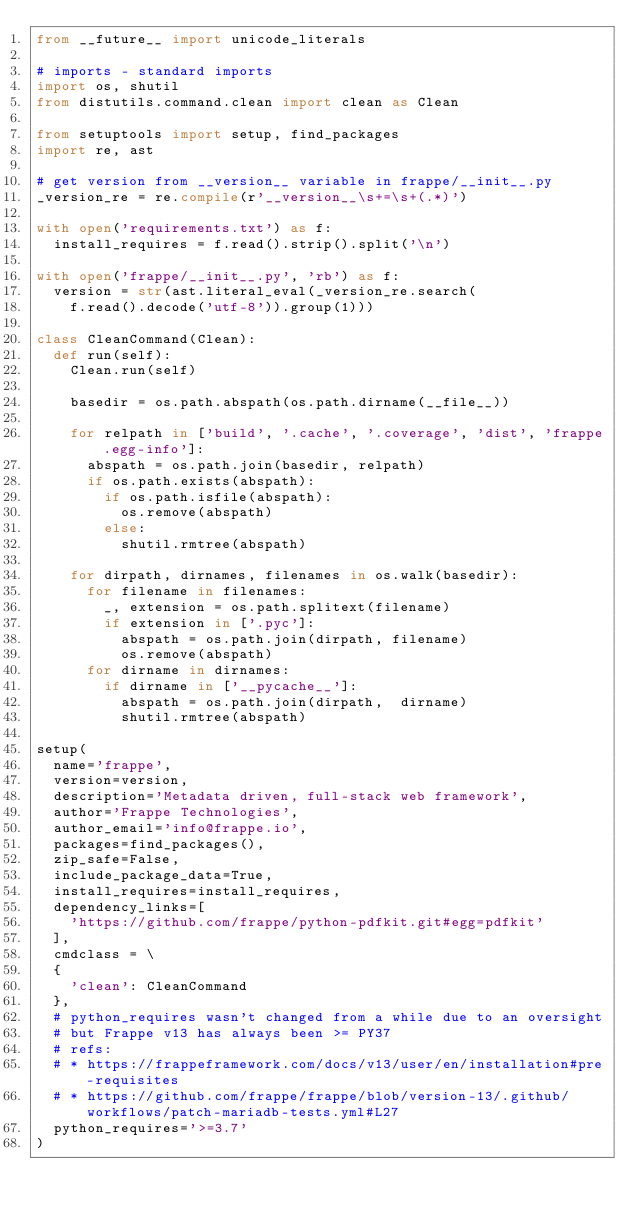<code> <loc_0><loc_0><loc_500><loc_500><_Python_>from __future__ import unicode_literals

# imports - standard imports
import os, shutil
from distutils.command.clean import clean as Clean

from setuptools import setup, find_packages
import re, ast

# get version from __version__ variable in frappe/__init__.py
_version_re = re.compile(r'__version__\s+=\s+(.*)')

with open('requirements.txt') as f:
	install_requires = f.read().strip().split('\n')

with open('frappe/__init__.py', 'rb') as f:
	version = str(ast.literal_eval(_version_re.search(
		f.read().decode('utf-8')).group(1)))

class CleanCommand(Clean):
	def run(self):
		Clean.run(self)

		basedir = os.path.abspath(os.path.dirname(__file__))

		for relpath in ['build', '.cache', '.coverage', 'dist', 'frappe.egg-info']:
			abspath = os.path.join(basedir, relpath)
			if os.path.exists(abspath):
				if os.path.isfile(abspath):
					os.remove(abspath)
				else:
					shutil.rmtree(abspath)

		for dirpath, dirnames, filenames in os.walk(basedir):
			for filename in filenames:
				_, extension = os.path.splitext(filename)
				if extension in ['.pyc']:
					abspath = os.path.join(dirpath, filename)
					os.remove(abspath)
			for dirname in dirnames:
				if dirname in ['__pycache__']:
					abspath = os.path.join(dirpath,  dirname)
					shutil.rmtree(abspath)

setup(
	name='frappe',
	version=version,
	description='Metadata driven, full-stack web framework',
	author='Frappe Technologies',
	author_email='info@frappe.io',
	packages=find_packages(),
	zip_safe=False,
	include_package_data=True,
	install_requires=install_requires,
	dependency_links=[
		'https://github.com/frappe/python-pdfkit.git#egg=pdfkit'
	],
	cmdclass = \
	{
		'clean': CleanCommand
	},
	# python_requires wasn't changed from a while due to an oversight
	# but Frappe v13 has always been >= PY37
	# refs:
	# * https://frappeframework.com/docs/v13/user/en/installation#pre-requisites
	# * https://github.com/frappe/frappe/blob/version-13/.github/workflows/patch-mariadb-tests.yml#L27
	python_requires='>=3.7'
)
</code> 